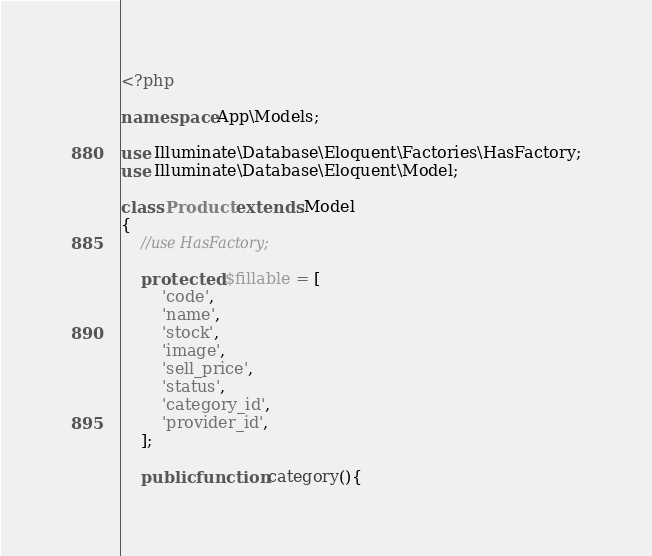Convert code to text. <code><loc_0><loc_0><loc_500><loc_500><_PHP_><?php

namespace App\Models;

use Illuminate\Database\Eloquent\Factories\HasFactory;
use Illuminate\Database\Eloquent\Model;

class Product extends Model
{
    //use HasFactory;

    protected $fillable = [
        'code',
        'name',
        'stock',
        'image',
        'sell_price',
        'status',
        'category_id',
        'provider_id',
    ];

    public function category(){</code> 